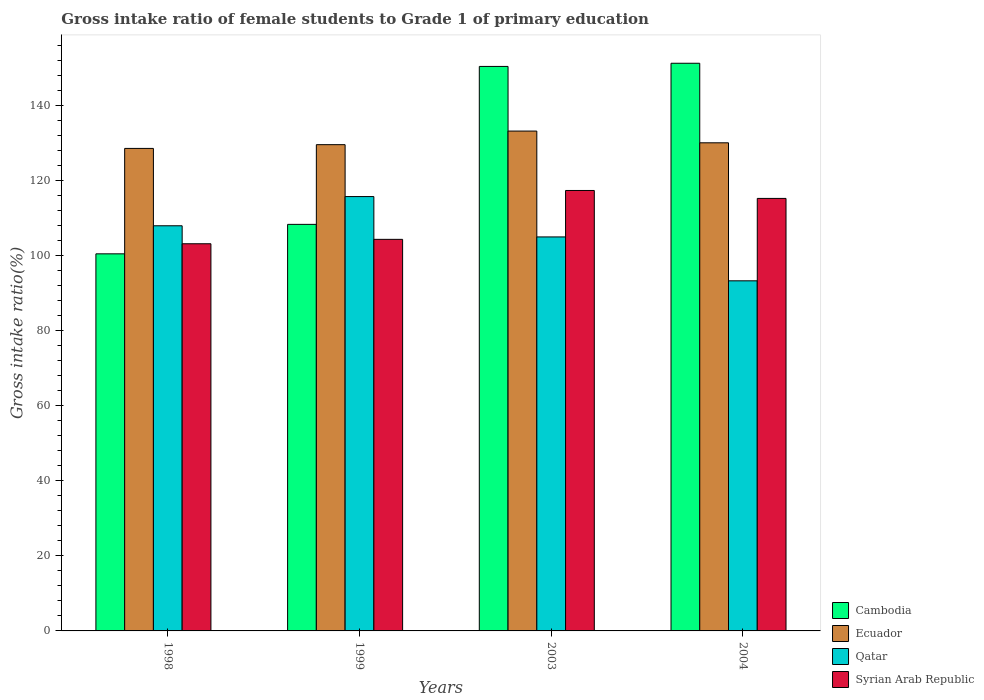How many different coloured bars are there?
Your answer should be compact. 4. Are the number of bars per tick equal to the number of legend labels?
Give a very brief answer. Yes. Are the number of bars on each tick of the X-axis equal?
Keep it short and to the point. Yes. How many bars are there on the 2nd tick from the right?
Provide a short and direct response. 4. In how many cases, is the number of bars for a given year not equal to the number of legend labels?
Give a very brief answer. 0. What is the gross intake ratio in Syrian Arab Republic in 1998?
Provide a succinct answer. 103.25. Across all years, what is the maximum gross intake ratio in Ecuador?
Make the answer very short. 133.3. Across all years, what is the minimum gross intake ratio in Qatar?
Make the answer very short. 93.37. What is the total gross intake ratio in Cambodia in the graph?
Provide a succinct answer. 510.9. What is the difference between the gross intake ratio in Ecuador in 1998 and that in 1999?
Ensure brevity in your answer.  -1. What is the difference between the gross intake ratio in Syrian Arab Republic in 1998 and the gross intake ratio in Qatar in 2004?
Your response must be concise. 9.88. What is the average gross intake ratio in Cambodia per year?
Offer a very short reply. 127.72. In the year 2003, what is the difference between the gross intake ratio in Ecuador and gross intake ratio in Qatar?
Offer a terse response. 28.23. In how many years, is the gross intake ratio in Qatar greater than 124 %?
Your answer should be compact. 0. What is the ratio of the gross intake ratio in Syrian Arab Republic in 1999 to that in 2004?
Your response must be concise. 0.91. Is the gross intake ratio in Qatar in 1999 less than that in 2004?
Your response must be concise. No. Is the difference between the gross intake ratio in Ecuador in 1999 and 2003 greater than the difference between the gross intake ratio in Qatar in 1999 and 2003?
Keep it short and to the point. No. What is the difference between the highest and the second highest gross intake ratio in Ecuador?
Your answer should be very brief. 3.13. What is the difference between the highest and the lowest gross intake ratio in Cambodia?
Provide a succinct answer. 50.82. Is the sum of the gross intake ratio in Qatar in 1998 and 1999 greater than the maximum gross intake ratio in Ecuador across all years?
Ensure brevity in your answer.  Yes. Is it the case that in every year, the sum of the gross intake ratio in Cambodia and gross intake ratio in Ecuador is greater than the sum of gross intake ratio in Qatar and gross intake ratio in Syrian Arab Republic?
Give a very brief answer. Yes. What does the 1st bar from the left in 2004 represents?
Offer a terse response. Cambodia. What does the 4th bar from the right in 1998 represents?
Your answer should be very brief. Cambodia. Is it the case that in every year, the sum of the gross intake ratio in Cambodia and gross intake ratio in Ecuador is greater than the gross intake ratio in Qatar?
Your response must be concise. Yes. What is the difference between two consecutive major ticks on the Y-axis?
Your response must be concise. 20. Are the values on the major ticks of Y-axis written in scientific E-notation?
Ensure brevity in your answer.  No. Does the graph contain any zero values?
Keep it short and to the point. No. Does the graph contain grids?
Your response must be concise. No. Where does the legend appear in the graph?
Your response must be concise. Bottom right. What is the title of the graph?
Your answer should be compact. Gross intake ratio of female students to Grade 1 of primary education. What is the label or title of the Y-axis?
Offer a very short reply. Gross intake ratio(%). What is the Gross intake ratio(%) in Cambodia in 1998?
Provide a short and direct response. 100.56. What is the Gross intake ratio(%) in Ecuador in 1998?
Make the answer very short. 128.67. What is the Gross intake ratio(%) in Qatar in 1998?
Keep it short and to the point. 108.04. What is the Gross intake ratio(%) in Syrian Arab Republic in 1998?
Offer a terse response. 103.25. What is the Gross intake ratio(%) in Cambodia in 1999?
Offer a very short reply. 108.42. What is the Gross intake ratio(%) of Ecuador in 1999?
Your answer should be very brief. 129.68. What is the Gross intake ratio(%) in Qatar in 1999?
Provide a short and direct response. 115.83. What is the Gross intake ratio(%) in Syrian Arab Republic in 1999?
Offer a very short reply. 104.42. What is the Gross intake ratio(%) in Cambodia in 2003?
Make the answer very short. 150.54. What is the Gross intake ratio(%) in Ecuador in 2003?
Your response must be concise. 133.3. What is the Gross intake ratio(%) of Qatar in 2003?
Your answer should be compact. 105.07. What is the Gross intake ratio(%) of Syrian Arab Republic in 2003?
Ensure brevity in your answer.  117.46. What is the Gross intake ratio(%) in Cambodia in 2004?
Keep it short and to the point. 151.38. What is the Gross intake ratio(%) of Ecuador in 2004?
Your answer should be compact. 130.17. What is the Gross intake ratio(%) of Qatar in 2004?
Give a very brief answer. 93.37. What is the Gross intake ratio(%) of Syrian Arab Republic in 2004?
Provide a succinct answer. 115.34. Across all years, what is the maximum Gross intake ratio(%) in Cambodia?
Provide a succinct answer. 151.38. Across all years, what is the maximum Gross intake ratio(%) of Ecuador?
Your answer should be compact. 133.3. Across all years, what is the maximum Gross intake ratio(%) in Qatar?
Make the answer very short. 115.83. Across all years, what is the maximum Gross intake ratio(%) of Syrian Arab Republic?
Keep it short and to the point. 117.46. Across all years, what is the minimum Gross intake ratio(%) of Cambodia?
Keep it short and to the point. 100.56. Across all years, what is the minimum Gross intake ratio(%) of Ecuador?
Your answer should be very brief. 128.67. Across all years, what is the minimum Gross intake ratio(%) of Qatar?
Make the answer very short. 93.37. Across all years, what is the minimum Gross intake ratio(%) of Syrian Arab Republic?
Your response must be concise. 103.25. What is the total Gross intake ratio(%) of Cambodia in the graph?
Provide a short and direct response. 510.9. What is the total Gross intake ratio(%) of Ecuador in the graph?
Your answer should be very brief. 521.82. What is the total Gross intake ratio(%) in Qatar in the graph?
Your answer should be compact. 422.31. What is the total Gross intake ratio(%) in Syrian Arab Republic in the graph?
Your answer should be compact. 440.47. What is the difference between the Gross intake ratio(%) of Cambodia in 1998 and that in 1999?
Your response must be concise. -7.86. What is the difference between the Gross intake ratio(%) of Ecuador in 1998 and that in 1999?
Make the answer very short. -1. What is the difference between the Gross intake ratio(%) of Qatar in 1998 and that in 1999?
Make the answer very short. -7.79. What is the difference between the Gross intake ratio(%) in Syrian Arab Republic in 1998 and that in 1999?
Your answer should be very brief. -1.18. What is the difference between the Gross intake ratio(%) in Cambodia in 1998 and that in 2003?
Give a very brief answer. -49.98. What is the difference between the Gross intake ratio(%) in Ecuador in 1998 and that in 2003?
Your response must be concise. -4.62. What is the difference between the Gross intake ratio(%) of Qatar in 1998 and that in 2003?
Provide a short and direct response. 2.97. What is the difference between the Gross intake ratio(%) in Syrian Arab Republic in 1998 and that in 2003?
Offer a terse response. -14.21. What is the difference between the Gross intake ratio(%) in Cambodia in 1998 and that in 2004?
Offer a terse response. -50.82. What is the difference between the Gross intake ratio(%) in Ecuador in 1998 and that in 2004?
Your answer should be very brief. -1.5. What is the difference between the Gross intake ratio(%) in Qatar in 1998 and that in 2004?
Provide a short and direct response. 14.68. What is the difference between the Gross intake ratio(%) of Syrian Arab Republic in 1998 and that in 2004?
Offer a very short reply. -12.1. What is the difference between the Gross intake ratio(%) of Cambodia in 1999 and that in 2003?
Offer a terse response. -42.12. What is the difference between the Gross intake ratio(%) in Ecuador in 1999 and that in 2003?
Keep it short and to the point. -3.62. What is the difference between the Gross intake ratio(%) in Qatar in 1999 and that in 2003?
Keep it short and to the point. 10.76. What is the difference between the Gross intake ratio(%) in Syrian Arab Republic in 1999 and that in 2003?
Ensure brevity in your answer.  -13.03. What is the difference between the Gross intake ratio(%) of Cambodia in 1999 and that in 2004?
Make the answer very short. -42.96. What is the difference between the Gross intake ratio(%) in Ecuador in 1999 and that in 2004?
Keep it short and to the point. -0.5. What is the difference between the Gross intake ratio(%) of Qatar in 1999 and that in 2004?
Make the answer very short. 22.46. What is the difference between the Gross intake ratio(%) in Syrian Arab Republic in 1999 and that in 2004?
Make the answer very short. -10.92. What is the difference between the Gross intake ratio(%) of Cambodia in 2003 and that in 2004?
Your response must be concise. -0.85. What is the difference between the Gross intake ratio(%) of Ecuador in 2003 and that in 2004?
Keep it short and to the point. 3.13. What is the difference between the Gross intake ratio(%) of Qatar in 2003 and that in 2004?
Ensure brevity in your answer.  11.7. What is the difference between the Gross intake ratio(%) in Syrian Arab Republic in 2003 and that in 2004?
Keep it short and to the point. 2.11. What is the difference between the Gross intake ratio(%) in Cambodia in 1998 and the Gross intake ratio(%) in Ecuador in 1999?
Provide a succinct answer. -29.12. What is the difference between the Gross intake ratio(%) of Cambodia in 1998 and the Gross intake ratio(%) of Qatar in 1999?
Keep it short and to the point. -15.27. What is the difference between the Gross intake ratio(%) in Cambodia in 1998 and the Gross intake ratio(%) in Syrian Arab Republic in 1999?
Provide a short and direct response. -3.86. What is the difference between the Gross intake ratio(%) of Ecuador in 1998 and the Gross intake ratio(%) of Qatar in 1999?
Offer a terse response. 12.84. What is the difference between the Gross intake ratio(%) in Ecuador in 1998 and the Gross intake ratio(%) in Syrian Arab Republic in 1999?
Provide a short and direct response. 24.25. What is the difference between the Gross intake ratio(%) in Qatar in 1998 and the Gross intake ratio(%) in Syrian Arab Republic in 1999?
Give a very brief answer. 3.62. What is the difference between the Gross intake ratio(%) of Cambodia in 1998 and the Gross intake ratio(%) of Ecuador in 2003?
Provide a succinct answer. -32.74. What is the difference between the Gross intake ratio(%) of Cambodia in 1998 and the Gross intake ratio(%) of Qatar in 2003?
Provide a succinct answer. -4.51. What is the difference between the Gross intake ratio(%) of Cambodia in 1998 and the Gross intake ratio(%) of Syrian Arab Republic in 2003?
Provide a short and direct response. -16.9. What is the difference between the Gross intake ratio(%) of Ecuador in 1998 and the Gross intake ratio(%) of Qatar in 2003?
Ensure brevity in your answer.  23.6. What is the difference between the Gross intake ratio(%) of Ecuador in 1998 and the Gross intake ratio(%) of Syrian Arab Republic in 2003?
Your response must be concise. 11.22. What is the difference between the Gross intake ratio(%) of Qatar in 1998 and the Gross intake ratio(%) of Syrian Arab Republic in 2003?
Keep it short and to the point. -9.41. What is the difference between the Gross intake ratio(%) in Cambodia in 1998 and the Gross intake ratio(%) in Ecuador in 2004?
Keep it short and to the point. -29.61. What is the difference between the Gross intake ratio(%) in Cambodia in 1998 and the Gross intake ratio(%) in Qatar in 2004?
Offer a terse response. 7.19. What is the difference between the Gross intake ratio(%) of Cambodia in 1998 and the Gross intake ratio(%) of Syrian Arab Republic in 2004?
Ensure brevity in your answer.  -14.78. What is the difference between the Gross intake ratio(%) of Ecuador in 1998 and the Gross intake ratio(%) of Qatar in 2004?
Your answer should be compact. 35.31. What is the difference between the Gross intake ratio(%) of Ecuador in 1998 and the Gross intake ratio(%) of Syrian Arab Republic in 2004?
Provide a succinct answer. 13.33. What is the difference between the Gross intake ratio(%) in Qatar in 1998 and the Gross intake ratio(%) in Syrian Arab Republic in 2004?
Provide a short and direct response. -7.3. What is the difference between the Gross intake ratio(%) in Cambodia in 1999 and the Gross intake ratio(%) in Ecuador in 2003?
Keep it short and to the point. -24.88. What is the difference between the Gross intake ratio(%) in Cambodia in 1999 and the Gross intake ratio(%) in Qatar in 2003?
Keep it short and to the point. 3.35. What is the difference between the Gross intake ratio(%) in Cambodia in 1999 and the Gross intake ratio(%) in Syrian Arab Republic in 2003?
Provide a short and direct response. -9.03. What is the difference between the Gross intake ratio(%) in Ecuador in 1999 and the Gross intake ratio(%) in Qatar in 2003?
Provide a succinct answer. 24.6. What is the difference between the Gross intake ratio(%) of Ecuador in 1999 and the Gross intake ratio(%) of Syrian Arab Republic in 2003?
Offer a very short reply. 12.22. What is the difference between the Gross intake ratio(%) in Qatar in 1999 and the Gross intake ratio(%) in Syrian Arab Republic in 2003?
Your answer should be compact. -1.62. What is the difference between the Gross intake ratio(%) in Cambodia in 1999 and the Gross intake ratio(%) in Ecuador in 2004?
Your answer should be very brief. -21.75. What is the difference between the Gross intake ratio(%) in Cambodia in 1999 and the Gross intake ratio(%) in Qatar in 2004?
Offer a very short reply. 15.05. What is the difference between the Gross intake ratio(%) of Cambodia in 1999 and the Gross intake ratio(%) of Syrian Arab Republic in 2004?
Your answer should be very brief. -6.92. What is the difference between the Gross intake ratio(%) in Ecuador in 1999 and the Gross intake ratio(%) in Qatar in 2004?
Provide a short and direct response. 36.31. What is the difference between the Gross intake ratio(%) of Ecuador in 1999 and the Gross intake ratio(%) of Syrian Arab Republic in 2004?
Ensure brevity in your answer.  14.33. What is the difference between the Gross intake ratio(%) of Qatar in 1999 and the Gross intake ratio(%) of Syrian Arab Republic in 2004?
Make the answer very short. 0.49. What is the difference between the Gross intake ratio(%) in Cambodia in 2003 and the Gross intake ratio(%) in Ecuador in 2004?
Provide a succinct answer. 20.36. What is the difference between the Gross intake ratio(%) of Cambodia in 2003 and the Gross intake ratio(%) of Qatar in 2004?
Your answer should be very brief. 57.17. What is the difference between the Gross intake ratio(%) of Cambodia in 2003 and the Gross intake ratio(%) of Syrian Arab Republic in 2004?
Your response must be concise. 35.19. What is the difference between the Gross intake ratio(%) of Ecuador in 2003 and the Gross intake ratio(%) of Qatar in 2004?
Your response must be concise. 39.93. What is the difference between the Gross intake ratio(%) of Ecuador in 2003 and the Gross intake ratio(%) of Syrian Arab Republic in 2004?
Offer a very short reply. 17.96. What is the difference between the Gross intake ratio(%) of Qatar in 2003 and the Gross intake ratio(%) of Syrian Arab Republic in 2004?
Provide a short and direct response. -10.27. What is the average Gross intake ratio(%) in Cambodia per year?
Offer a very short reply. 127.72. What is the average Gross intake ratio(%) of Ecuador per year?
Ensure brevity in your answer.  130.46. What is the average Gross intake ratio(%) of Qatar per year?
Ensure brevity in your answer.  105.58. What is the average Gross intake ratio(%) in Syrian Arab Republic per year?
Your answer should be compact. 110.12. In the year 1998, what is the difference between the Gross intake ratio(%) of Cambodia and Gross intake ratio(%) of Ecuador?
Your answer should be very brief. -28.12. In the year 1998, what is the difference between the Gross intake ratio(%) of Cambodia and Gross intake ratio(%) of Qatar?
Your answer should be very brief. -7.48. In the year 1998, what is the difference between the Gross intake ratio(%) of Cambodia and Gross intake ratio(%) of Syrian Arab Republic?
Give a very brief answer. -2.69. In the year 1998, what is the difference between the Gross intake ratio(%) of Ecuador and Gross intake ratio(%) of Qatar?
Keep it short and to the point. 20.63. In the year 1998, what is the difference between the Gross intake ratio(%) in Ecuador and Gross intake ratio(%) in Syrian Arab Republic?
Provide a succinct answer. 25.43. In the year 1998, what is the difference between the Gross intake ratio(%) in Qatar and Gross intake ratio(%) in Syrian Arab Republic?
Offer a terse response. 4.8. In the year 1999, what is the difference between the Gross intake ratio(%) in Cambodia and Gross intake ratio(%) in Ecuador?
Provide a succinct answer. -21.25. In the year 1999, what is the difference between the Gross intake ratio(%) of Cambodia and Gross intake ratio(%) of Qatar?
Your answer should be very brief. -7.41. In the year 1999, what is the difference between the Gross intake ratio(%) of Cambodia and Gross intake ratio(%) of Syrian Arab Republic?
Your answer should be very brief. 4. In the year 1999, what is the difference between the Gross intake ratio(%) in Ecuador and Gross intake ratio(%) in Qatar?
Provide a short and direct response. 13.85. In the year 1999, what is the difference between the Gross intake ratio(%) in Ecuador and Gross intake ratio(%) in Syrian Arab Republic?
Your response must be concise. 25.25. In the year 1999, what is the difference between the Gross intake ratio(%) of Qatar and Gross intake ratio(%) of Syrian Arab Republic?
Keep it short and to the point. 11.41. In the year 2003, what is the difference between the Gross intake ratio(%) of Cambodia and Gross intake ratio(%) of Ecuador?
Provide a short and direct response. 17.24. In the year 2003, what is the difference between the Gross intake ratio(%) in Cambodia and Gross intake ratio(%) in Qatar?
Your answer should be very brief. 45.46. In the year 2003, what is the difference between the Gross intake ratio(%) of Cambodia and Gross intake ratio(%) of Syrian Arab Republic?
Offer a very short reply. 33.08. In the year 2003, what is the difference between the Gross intake ratio(%) of Ecuador and Gross intake ratio(%) of Qatar?
Offer a very short reply. 28.23. In the year 2003, what is the difference between the Gross intake ratio(%) in Ecuador and Gross intake ratio(%) in Syrian Arab Republic?
Provide a short and direct response. 15.84. In the year 2003, what is the difference between the Gross intake ratio(%) of Qatar and Gross intake ratio(%) of Syrian Arab Republic?
Make the answer very short. -12.38. In the year 2004, what is the difference between the Gross intake ratio(%) of Cambodia and Gross intake ratio(%) of Ecuador?
Provide a succinct answer. 21.21. In the year 2004, what is the difference between the Gross intake ratio(%) of Cambodia and Gross intake ratio(%) of Qatar?
Provide a succinct answer. 58.02. In the year 2004, what is the difference between the Gross intake ratio(%) of Cambodia and Gross intake ratio(%) of Syrian Arab Republic?
Provide a short and direct response. 36.04. In the year 2004, what is the difference between the Gross intake ratio(%) of Ecuador and Gross intake ratio(%) of Qatar?
Offer a terse response. 36.81. In the year 2004, what is the difference between the Gross intake ratio(%) of Ecuador and Gross intake ratio(%) of Syrian Arab Republic?
Keep it short and to the point. 14.83. In the year 2004, what is the difference between the Gross intake ratio(%) in Qatar and Gross intake ratio(%) in Syrian Arab Republic?
Keep it short and to the point. -21.98. What is the ratio of the Gross intake ratio(%) in Cambodia in 1998 to that in 1999?
Ensure brevity in your answer.  0.93. What is the ratio of the Gross intake ratio(%) in Qatar in 1998 to that in 1999?
Keep it short and to the point. 0.93. What is the ratio of the Gross intake ratio(%) in Syrian Arab Republic in 1998 to that in 1999?
Provide a short and direct response. 0.99. What is the ratio of the Gross intake ratio(%) of Cambodia in 1998 to that in 2003?
Provide a short and direct response. 0.67. What is the ratio of the Gross intake ratio(%) of Ecuador in 1998 to that in 2003?
Give a very brief answer. 0.97. What is the ratio of the Gross intake ratio(%) of Qatar in 1998 to that in 2003?
Ensure brevity in your answer.  1.03. What is the ratio of the Gross intake ratio(%) of Syrian Arab Republic in 1998 to that in 2003?
Provide a succinct answer. 0.88. What is the ratio of the Gross intake ratio(%) in Cambodia in 1998 to that in 2004?
Ensure brevity in your answer.  0.66. What is the ratio of the Gross intake ratio(%) of Qatar in 1998 to that in 2004?
Ensure brevity in your answer.  1.16. What is the ratio of the Gross intake ratio(%) in Syrian Arab Republic in 1998 to that in 2004?
Ensure brevity in your answer.  0.9. What is the ratio of the Gross intake ratio(%) of Cambodia in 1999 to that in 2003?
Provide a short and direct response. 0.72. What is the ratio of the Gross intake ratio(%) in Ecuador in 1999 to that in 2003?
Give a very brief answer. 0.97. What is the ratio of the Gross intake ratio(%) of Qatar in 1999 to that in 2003?
Provide a short and direct response. 1.1. What is the ratio of the Gross intake ratio(%) in Syrian Arab Republic in 1999 to that in 2003?
Keep it short and to the point. 0.89. What is the ratio of the Gross intake ratio(%) in Cambodia in 1999 to that in 2004?
Your answer should be very brief. 0.72. What is the ratio of the Gross intake ratio(%) of Ecuador in 1999 to that in 2004?
Make the answer very short. 1. What is the ratio of the Gross intake ratio(%) in Qatar in 1999 to that in 2004?
Your response must be concise. 1.24. What is the ratio of the Gross intake ratio(%) in Syrian Arab Republic in 1999 to that in 2004?
Provide a short and direct response. 0.91. What is the ratio of the Gross intake ratio(%) in Cambodia in 2003 to that in 2004?
Provide a succinct answer. 0.99. What is the ratio of the Gross intake ratio(%) in Qatar in 2003 to that in 2004?
Provide a short and direct response. 1.13. What is the ratio of the Gross intake ratio(%) in Syrian Arab Republic in 2003 to that in 2004?
Your answer should be very brief. 1.02. What is the difference between the highest and the second highest Gross intake ratio(%) in Cambodia?
Offer a very short reply. 0.85. What is the difference between the highest and the second highest Gross intake ratio(%) in Ecuador?
Your answer should be compact. 3.13. What is the difference between the highest and the second highest Gross intake ratio(%) in Qatar?
Ensure brevity in your answer.  7.79. What is the difference between the highest and the second highest Gross intake ratio(%) of Syrian Arab Republic?
Provide a short and direct response. 2.11. What is the difference between the highest and the lowest Gross intake ratio(%) of Cambodia?
Ensure brevity in your answer.  50.82. What is the difference between the highest and the lowest Gross intake ratio(%) of Ecuador?
Offer a terse response. 4.62. What is the difference between the highest and the lowest Gross intake ratio(%) in Qatar?
Offer a very short reply. 22.46. What is the difference between the highest and the lowest Gross intake ratio(%) of Syrian Arab Republic?
Provide a succinct answer. 14.21. 